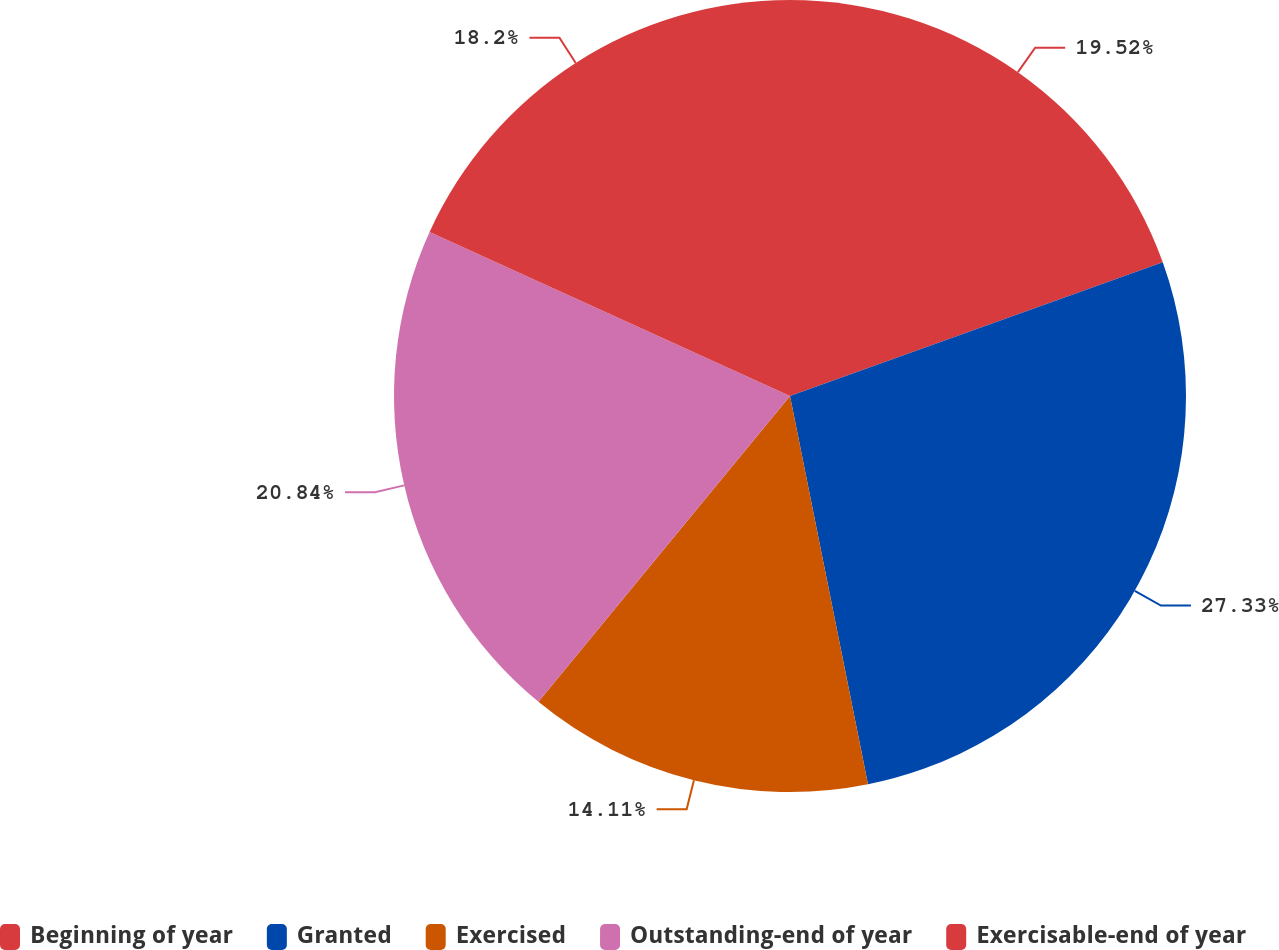Convert chart to OTSL. <chart><loc_0><loc_0><loc_500><loc_500><pie_chart><fcel>Beginning of year<fcel>Granted<fcel>Exercised<fcel>Outstanding-end of year<fcel>Exercisable-end of year<nl><fcel>19.52%<fcel>27.32%<fcel>14.11%<fcel>20.84%<fcel>18.2%<nl></chart> 